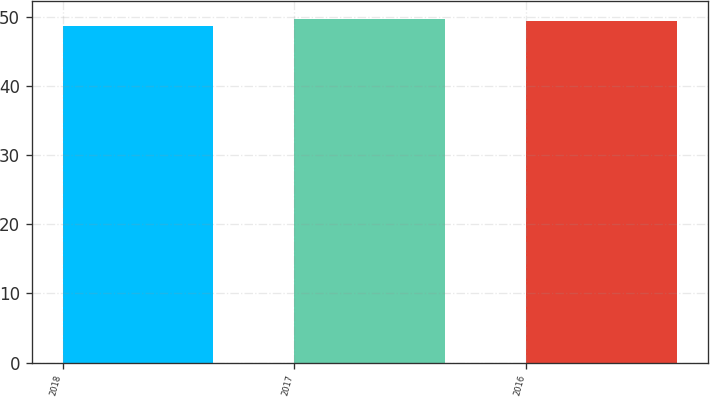Convert chart to OTSL. <chart><loc_0><loc_0><loc_500><loc_500><bar_chart><fcel>2018<fcel>2017<fcel>2016<nl><fcel>48.7<fcel>49.8<fcel>49.5<nl></chart> 